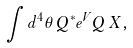Convert formula to latex. <formula><loc_0><loc_0><loc_500><loc_500>\int d ^ { 4 } \theta \, Q ^ { * } e ^ { V } Q \, X ,</formula> 